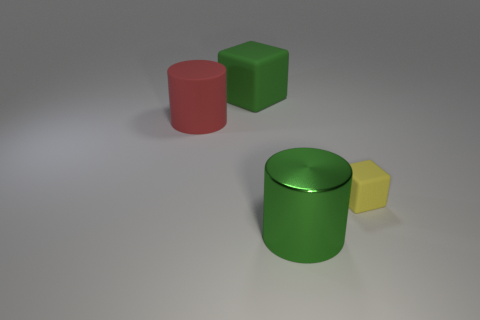Add 2 large green matte objects. How many objects exist? 6 Add 4 yellow things. How many yellow things are left? 5 Add 1 green objects. How many green objects exist? 3 Subtract 0 red spheres. How many objects are left? 4 Subtract all red rubber cylinders. Subtract all big metallic things. How many objects are left? 2 